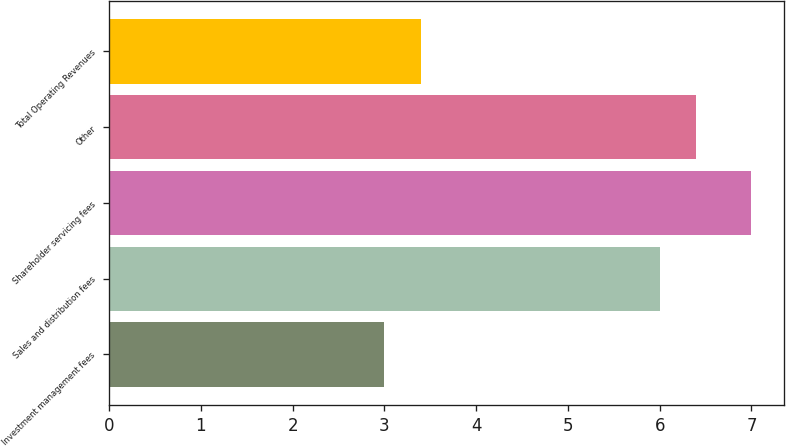Convert chart to OTSL. <chart><loc_0><loc_0><loc_500><loc_500><bar_chart><fcel>Investment management fees<fcel>Sales and distribution fees<fcel>Shareholder servicing fees<fcel>Other<fcel>Total Operating Revenues<nl><fcel>3<fcel>6<fcel>7<fcel>6.4<fcel>3.4<nl></chart> 